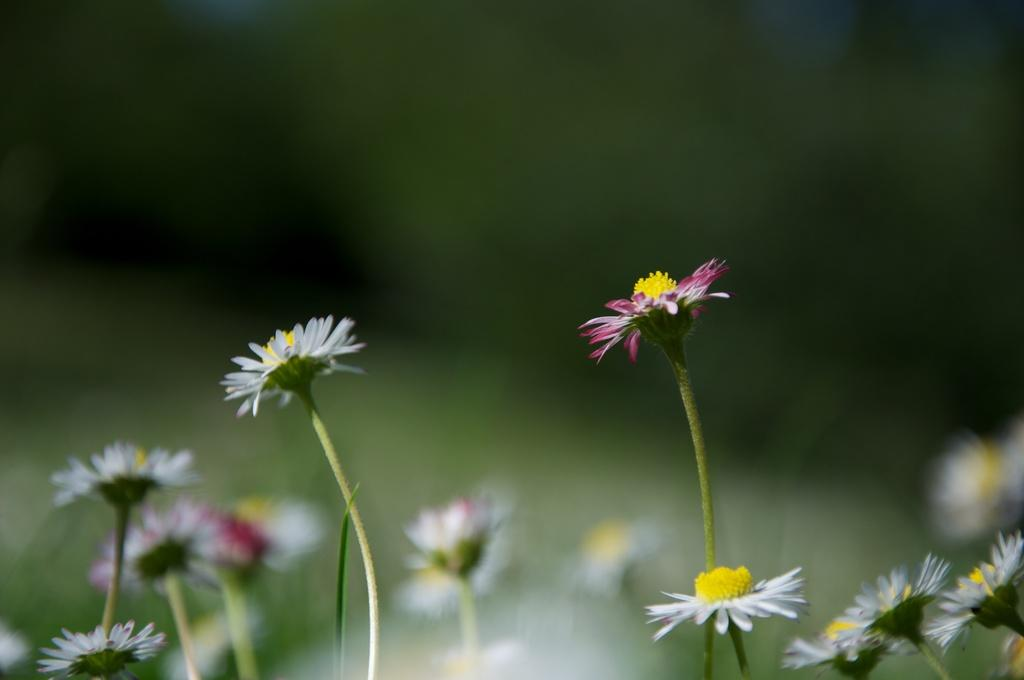What type of plants can be seen in the image? There are plants with flowers in the image. Can you describe the background of the image? The background of the image is blurred. How many deer are visible in the image? There are no deer present in the image; it features plants with flowers and a blurred background. What is the profit margin of the plants in the image? There is no information about profit margins in the image, as it focuses on the visual appearance of the plants with flowers and the blurred background. 